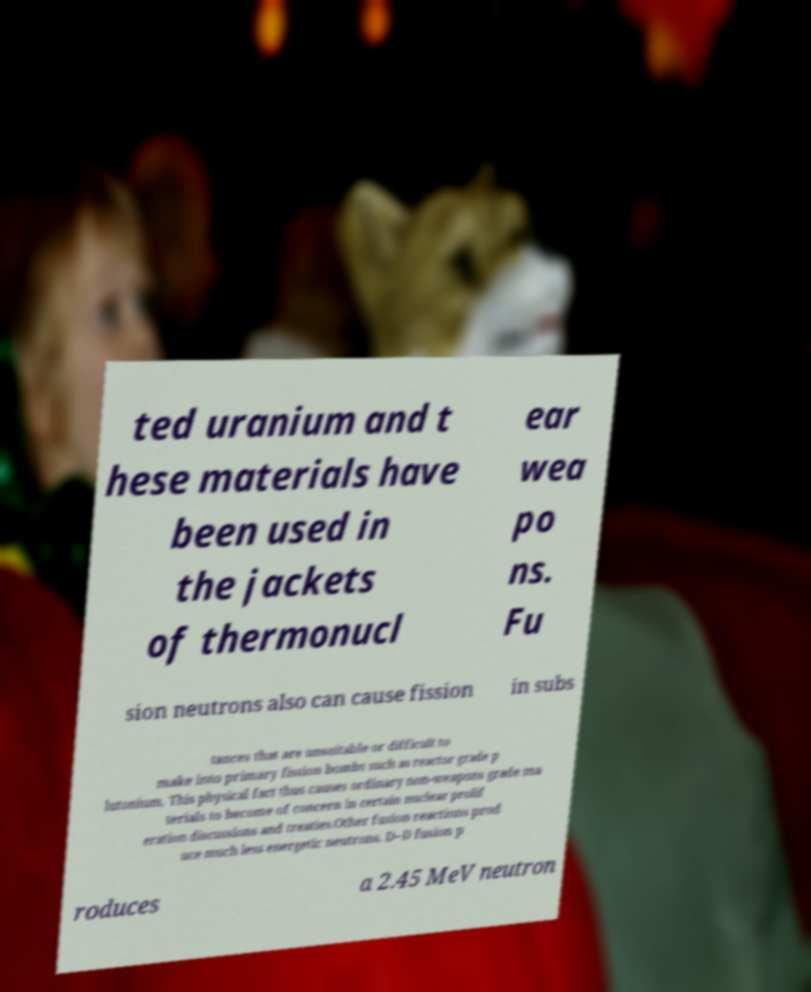Could you assist in decoding the text presented in this image and type it out clearly? ted uranium and t hese materials have been used in the jackets of thermonucl ear wea po ns. Fu sion neutrons also can cause fission in subs tances that are unsuitable or difficult to make into primary fission bombs such as reactor grade p lutonium. This physical fact thus causes ordinary non-weapons grade ma terials to become of concern in certain nuclear prolif eration discussions and treaties.Other fusion reactions prod uce much less energetic neutrons. D–D fusion p roduces a 2.45 MeV neutron 